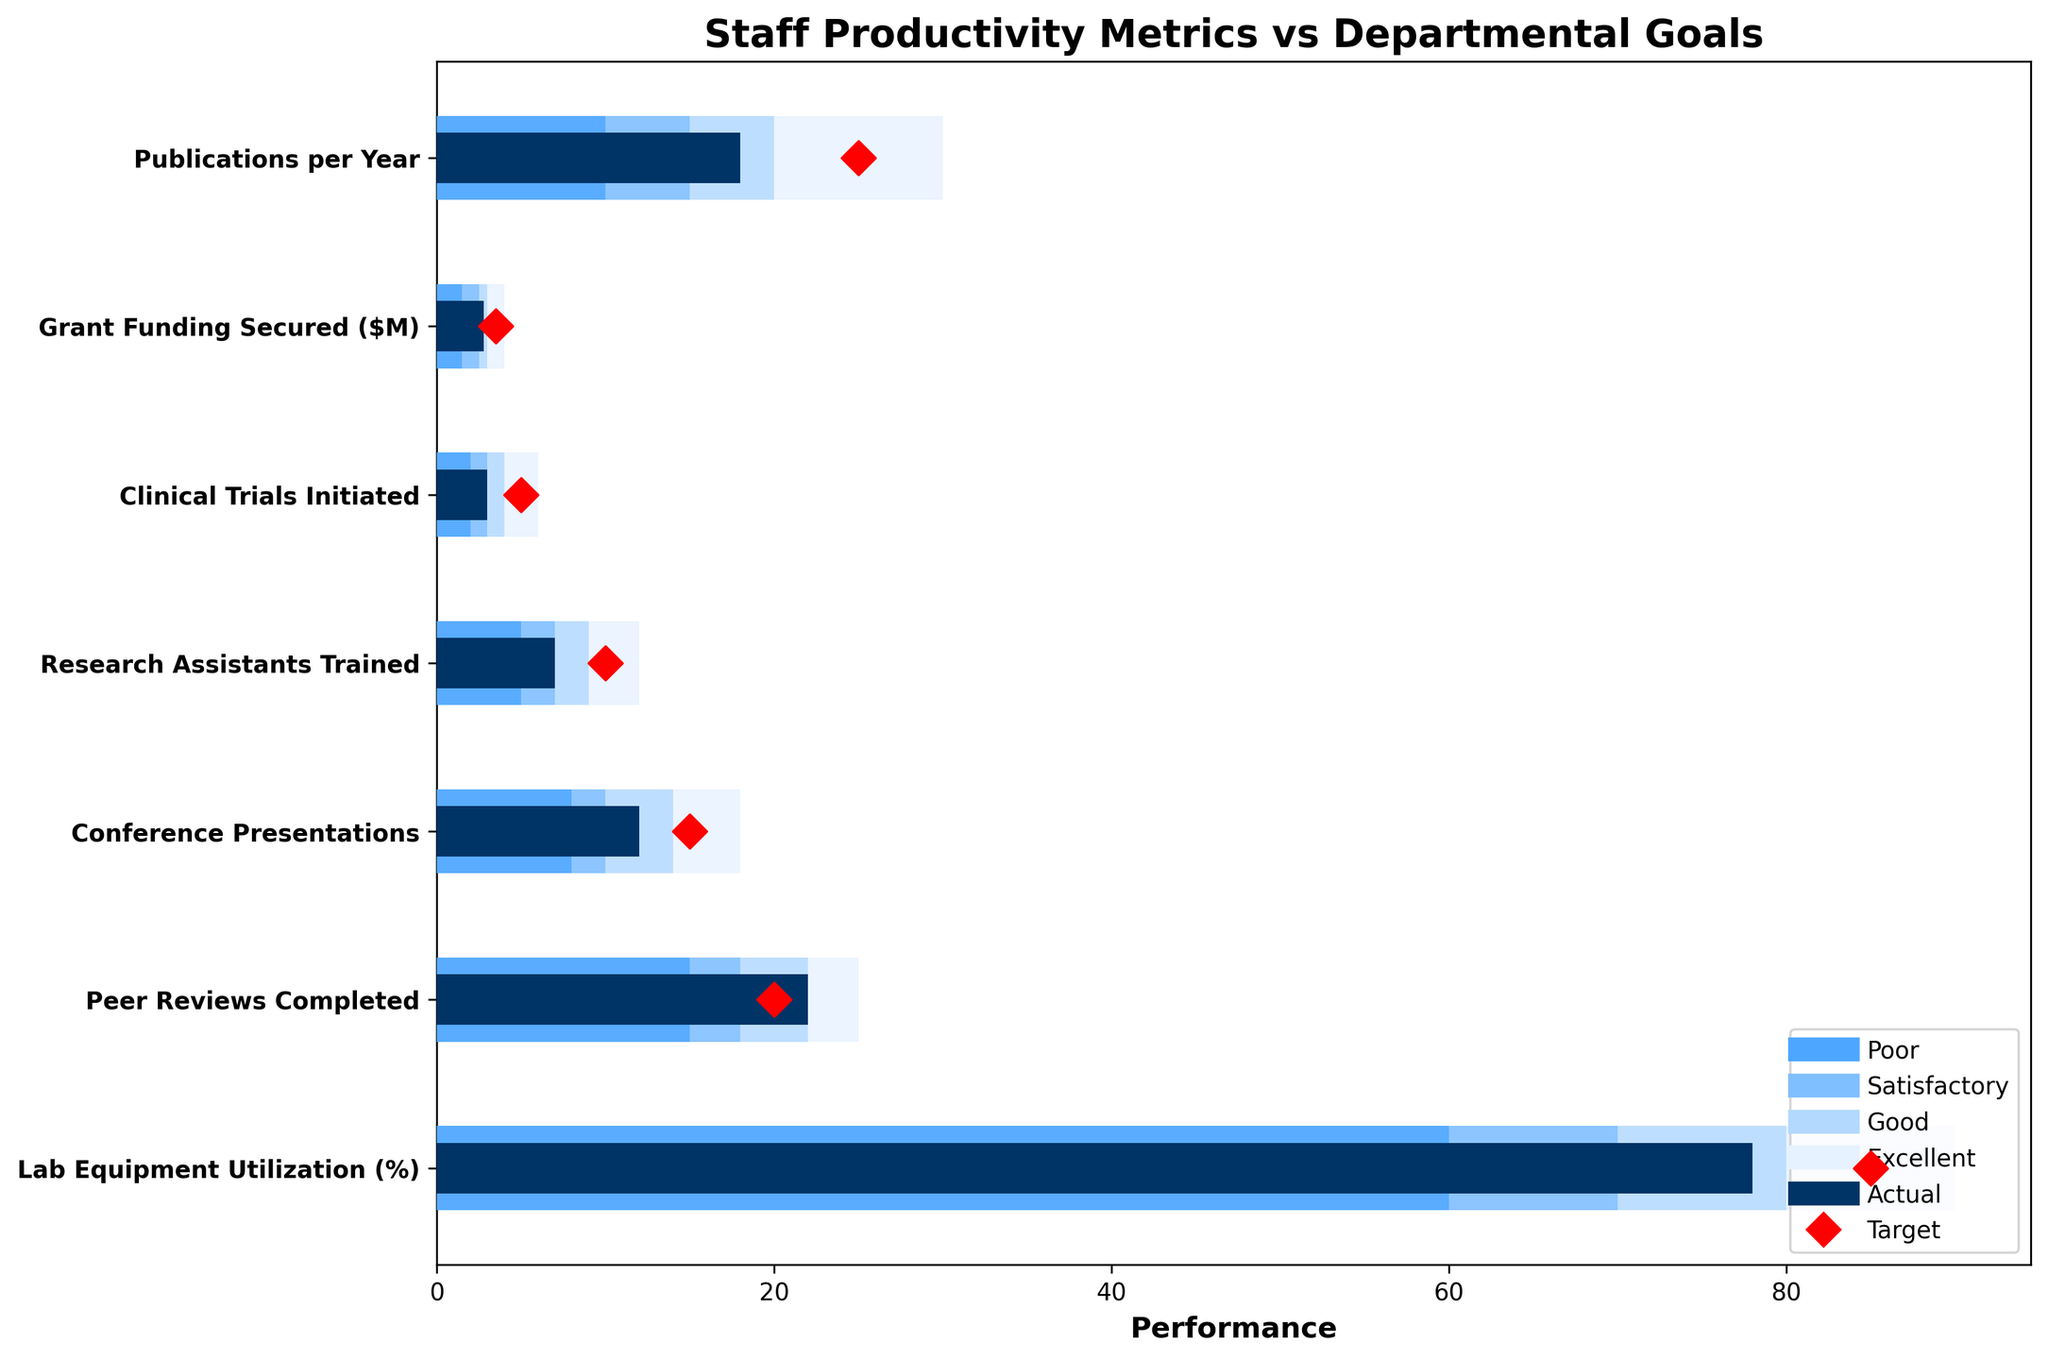What is the title of the figure? The title is found at the top of the plot and summarizes the main topic of the plot, which is "Staff Productivity Metrics vs Departmental Goals".
Answer: Staff Productivity Metrics vs Departmental Goals How many metrics are evaluated in this figure? Count the number of unique metrics listed along the y-axis, each representing a different staff productivity metric.
Answer: 7 Which metric has the closest actual value to its target? Find the metrics where the actual bar (dark blue) is closest to the red target marker and measure the difference. "Peer Reviews Completed" is closest as the actual value 22 is very close to the target value 20.
Answer: Peer Reviews Completed For "Grant Funding Secured", what is the actual funding secured and what is the target? Look at the "Grant Funding Secured" row and note the length of the dark blue bar (2.8) and the position of the red target marker (3.5).
Answer: 2.8, 3.5 Which productivity metric falls into the 'Excellent' category based on its actual value? Look for a dark blue bar that extends into the 'Excellent' (lightest blue) range. None of the metrics has actual values that reach into the 'Excellent' category (values corresponding to the lightest blue range).
Answer: None What is the performance range classified as 'Good' for "Conference Presentations"? The width of the 'Good' bar for "Conference Presentations" must be examined. It ranges from 10 to 14 as seen by the color coding.
Answer: 10-14 Which metric fell short of reaching its ‘Satisfactory’ range based on actual performance? Compare each metric’s actual value to its ‘Satisfactory’ range. The actual value for "Grant Funding Secured" (2.8) does not reach the ‘Satisfactory’ range (2.5-3.0).
Answer: Grant Funding Secured What is the sum of the targets for “Publications per Year” and “Clinical Trials Initiated”? Add the target values for both metrics: 25 (Publications per Year) + 5 (Clinical Trials Initiated) = 30.
Answer: 30 What is the difference between the target and actual value for "Research Assistants Trained"? Subtract the actual value (7) from the target value (10): 10 - 7 = 3.
Answer: 3 Which metrics have actual values greater than their targets? Identify metrics where the dark blue bars are longer than the distance to the red diamond targets. "Peer Reviews Completed" (22, target 20) and "Lab Equipment Utilization" (78%, target 85%) fall into this category.
Answer: Peer Reviews Completed, Lab Equipment Utilization 